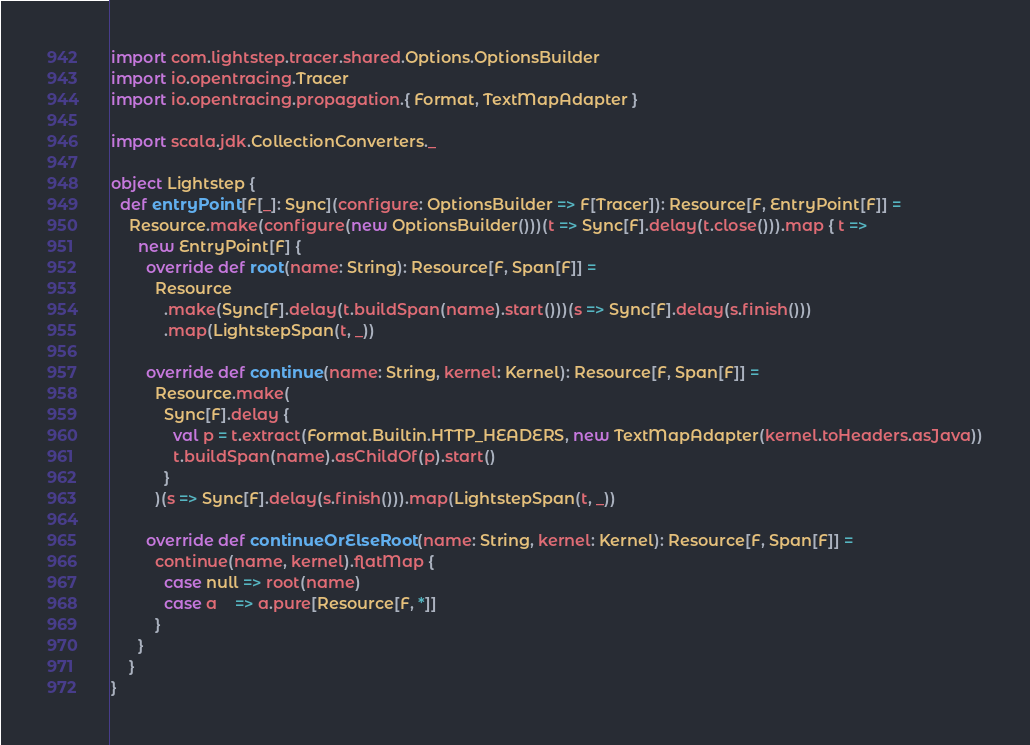<code> <loc_0><loc_0><loc_500><loc_500><_Scala_>import com.lightstep.tracer.shared.Options.OptionsBuilder
import io.opentracing.Tracer
import io.opentracing.propagation.{ Format, TextMapAdapter }

import scala.jdk.CollectionConverters._

object Lightstep {
  def entryPoint[F[_]: Sync](configure: OptionsBuilder => F[Tracer]): Resource[F, EntryPoint[F]] =
    Resource.make(configure(new OptionsBuilder()))(t => Sync[F].delay(t.close())).map { t =>
      new EntryPoint[F] {
        override def root(name: String): Resource[F, Span[F]] =
          Resource
            .make(Sync[F].delay(t.buildSpan(name).start()))(s => Sync[F].delay(s.finish()))
            .map(LightstepSpan(t, _))

        override def continue(name: String, kernel: Kernel): Resource[F, Span[F]] =
          Resource.make(
            Sync[F].delay {
              val p = t.extract(Format.Builtin.HTTP_HEADERS, new TextMapAdapter(kernel.toHeaders.asJava))
              t.buildSpan(name).asChildOf(p).start()
            }
          )(s => Sync[F].delay(s.finish())).map(LightstepSpan(t, _))

        override def continueOrElseRoot(name: String, kernel: Kernel): Resource[F, Span[F]] =
          continue(name, kernel).flatMap {
            case null => root(name)
            case a    => a.pure[Resource[F, *]]
          }
      }
    }
}
</code> 